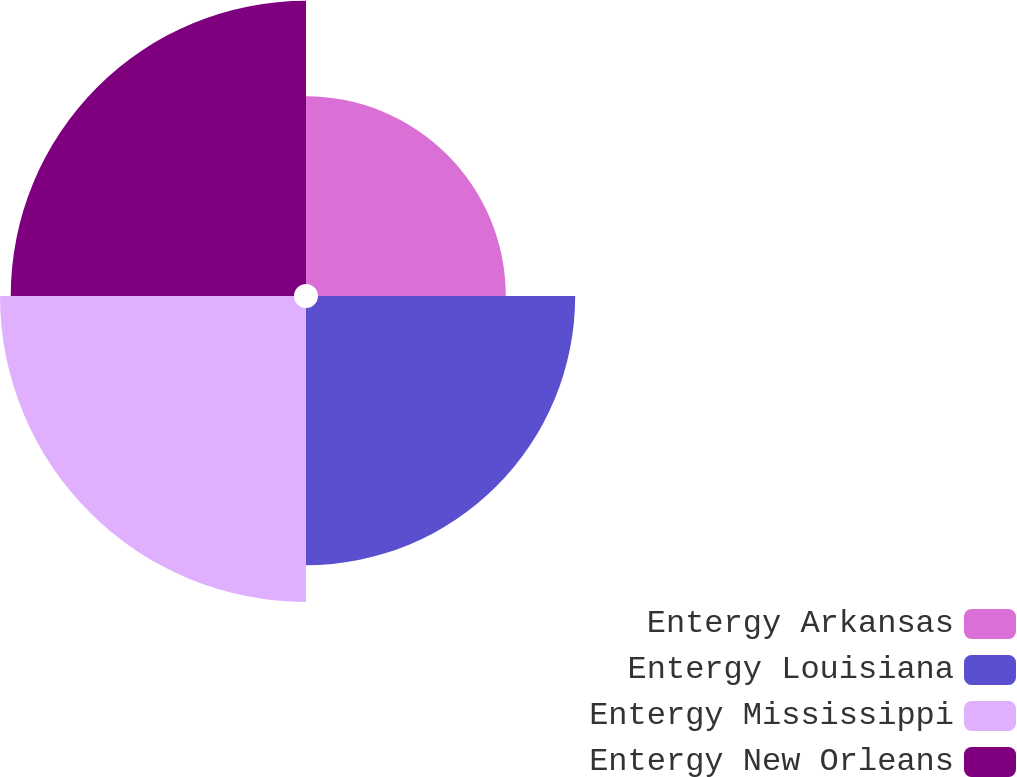Convert chart. <chart><loc_0><loc_0><loc_500><loc_500><pie_chart><fcel>Entergy Arkansas<fcel>Entergy Louisiana<fcel>Entergy Mississippi<fcel>Entergy New Orleans<nl><fcel>18.37%<fcel>25.16%<fcel>28.76%<fcel>27.71%<nl></chart> 